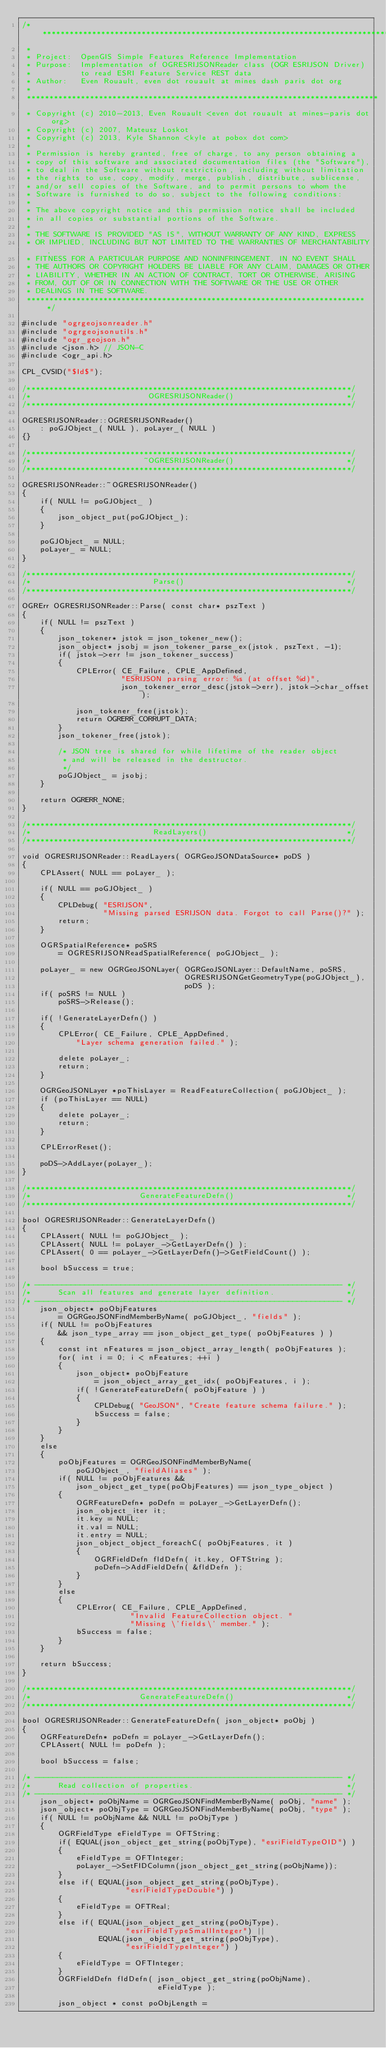<code> <loc_0><loc_0><loc_500><loc_500><_C++_>/******************************************************************************
 *
 * Project:  OpenGIS Simple Features Reference Implementation
 * Purpose:  Implementation of OGRESRIJSONReader class (OGR ESRIJSON Driver)
 *           to read ESRI Feature Service REST data
 * Author:   Even Rouault, even dot rouault at mines dash paris dot org
 *
 ******************************************************************************
 * Copyright (c) 2010-2013, Even Rouault <even dot rouault at mines-paris dot org>
 * Copyright (c) 2007, Mateusz Loskot
 * Copyright (c) 2013, Kyle Shannon <kyle at pobox dot com>
 *
 * Permission is hereby granted, free of charge, to any person obtaining a
 * copy of this software and associated documentation files (the "Software"),
 * to deal in the Software without restriction, including without limitation
 * the rights to use, copy, modify, merge, publish, distribute, sublicense,
 * and/or sell copies of the Software, and to permit persons to whom the
 * Software is furnished to do so, subject to the following conditions:
 *
 * The above copyright notice and this permission notice shall be included
 * in all copies or substantial portions of the Software.
 *
 * THE SOFTWARE IS PROVIDED "AS IS", WITHOUT WARRANTY OF ANY KIND, EXPRESS
 * OR IMPLIED, INCLUDING BUT NOT LIMITED TO THE WARRANTIES OF MERCHANTABILITY,
 * FITNESS FOR A PARTICULAR PURPOSE AND NONINFRINGEMENT. IN NO EVENT SHALL
 * THE AUTHORS OR COPYRIGHT HOLDERS BE LIABLE FOR ANY CLAIM, DAMAGES OR OTHER
 * LIABILITY, WHETHER IN AN ACTION OF CONTRACT, TORT OR OTHERWISE, ARISING
 * FROM, OUT OF OR IN CONNECTION WITH THE SOFTWARE OR THE USE OR OTHER
 * DEALINGS IN THE SOFTWARE.
 ****************************************************************************/

#include "ogrgeojsonreader.h"
#include "ogrgeojsonutils.h"
#include "ogr_geojson.h"
#include <json.h> // JSON-C
#include <ogr_api.h>

CPL_CVSID("$Id$");

/************************************************************************/
/*                          OGRESRIJSONReader()                         */
/************************************************************************/

OGRESRIJSONReader::OGRESRIJSONReader()
    : poGJObject_( NULL ), poLayer_( NULL )
{}

/************************************************************************/
/*                         ~OGRESRIJSONReader()                         */
/************************************************************************/

OGRESRIJSONReader::~OGRESRIJSONReader()
{
    if( NULL != poGJObject_ )
    {
        json_object_put(poGJObject_);
    }

    poGJObject_ = NULL;
    poLayer_ = NULL;
}

/************************************************************************/
/*                           Parse()                                    */
/************************************************************************/

OGRErr OGRESRIJSONReader::Parse( const char* pszText )
{
    if( NULL != pszText )
    {
        json_tokener* jstok = json_tokener_new();
        json_object* jsobj = json_tokener_parse_ex(jstok, pszText, -1);
        if( jstok->err != json_tokener_success)
        {
            CPLError( CE_Failure, CPLE_AppDefined,
                      "ESRIJSON parsing error: %s (at offset %d)",
                      json_tokener_error_desc(jstok->err), jstok->char_offset);

            json_tokener_free(jstok);
            return OGRERR_CORRUPT_DATA;
        }
        json_tokener_free(jstok);

        /* JSON tree is shared for while lifetime of the reader object
         * and will be released in the destructor.
         */
        poGJObject_ = jsobj;
    }

    return OGRERR_NONE;
}

/************************************************************************/
/*                           ReadLayers()                               */
/************************************************************************/

void OGRESRIJSONReader::ReadLayers( OGRGeoJSONDataSource* poDS )
{
    CPLAssert( NULL == poLayer_ );

    if( NULL == poGJObject_ )
    {
        CPLDebug( "ESRIJSON",
                  "Missing parsed ESRIJSON data. Forgot to call Parse()?" );
        return;
    }

    OGRSpatialReference* poSRS
        = OGRESRIJSONReadSpatialReference( poGJObject_ );

    poLayer_ = new OGRGeoJSONLayer( OGRGeoJSONLayer::DefaultName, poSRS,
                                    OGRESRIJSONGetGeometryType(poGJObject_),
                                    poDS );
    if( poSRS != NULL )
        poSRS->Release();

    if( !GenerateLayerDefn() )
    {
        CPLError( CE_Failure, CPLE_AppDefined,
            "Layer schema generation failed." );

        delete poLayer_;
        return;
    }

    OGRGeoJSONLayer *poThisLayer = ReadFeatureCollection( poGJObject_ );
    if (poThisLayer == NULL)
    {
        delete poLayer_;
        return;
    }

    CPLErrorReset();

    poDS->AddLayer(poLayer_);
}

/************************************************************************/
/*                        GenerateFeatureDefn()                         */
/************************************************************************/

bool OGRESRIJSONReader::GenerateLayerDefn()
{
    CPLAssert( NULL != poGJObject_ );
    CPLAssert( NULL != poLayer_->GetLayerDefn() );
    CPLAssert( 0 == poLayer_->GetLayerDefn()->GetFieldCount() );

    bool bSuccess = true;

/* -------------------------------------------------------------------- */
/*      Scan all features and generate layer definition.                */
/* -------------------------------------------------------------------- */
    json_object* poObjFeatures
        = OGRGeoJSONFindMemberByName( poGJObject_, "fields" );
    if( NULL != poObjFeatures
        && json_type_array == json_object_get_type( poObjFeatures ) )
    {
        const int nFeatures = json_object_array_length( poObjFeatures );
        for( int i = 0; i < nFeatures; ++i )
        {
            json_object* poObjFeature
                = json_object_array_get_idx( poObjFeatures, i );
            if( !GenerateFeatureDefn( poObjFeature ) )
            {
                CPLDebug( "GeoJSON", "Create feature schema failure." );
                bSuccess = false;
            }
        }
    }
    else
    {
        poObjFeatures = OGRGeoJSONFindMemberByName(
            poGJObject_, "fieldAliases" );
        if( NULL != poObjFeatures &&
            json_object_get_type(poObjFeatures) == json_type_object )
        {
            OGRFeatureDefn* poDefn = poLayer_->GetLayerDefn();
            json_object_iter it;
            it.key = NULL;
            it.val = NULL;
            it.entry = NULL;
            json_object_object_foreachC( poObjFeatures, it )
            {
                OGRFieldDefn fldDefn( it.key, OFTString );
                poDefn->AddFieldDefn( &fldDefn );
            }
        }
        else
        {
            CPLError( CE_Failure, CPLE_AppDefined,
                        "Invalid FeatureCollection object. "
                        "Missing \'fields\' member." );
            bSuccess = false;
        }
    }

    return bSuccess;
}

/************************************************************************/
/*                        GenerateFeatureDefn()                         */
/************************************************************************/

bool OGRESRIJSONReader::GenerateFeatureDefn( json_object* poObj )
{
    OGRFeatureDefn* poDefn = poLayer_->GetLayerDefn();
    CPLAssert( NULL != poDefn );

    bool bSuccess = false;

/* -------------------------------------------------------------------- */
/*      Read collection of properties.                                  */
/* -------------------------------------------------------------------- */
    json_object* poObjName = OGRGeoJSONFindMemberByName( poObj, "name" );
    json_object* poObjType = OGRGeoJSONFindMemberByName( poObj, "type" );
    if( NULL != poObjName && NULL != poObjType )
    {
        OGRFieldType eFieldType = OFTString;
        if( EQUAL(json_object_get_string(poObjType), "esriFieldTypeOID") )
        {
            eFieldType = OFTInteger;
            poLayer_->SetFIDColumn(json_object_get_string(poObjName));
        }
        else if( EQUAL(json_object_get_string(poObjType),
                       "esriFieldTypeDouble") )
        {
            eFieldType = OFTReal;
        }
        else if( EQUAL(json_object_get_string(poObjType),
                       "esriFieldTypeSmallInteger") ||
                 EQUAL(json_object_get_string(poObjType),
                       "esriFieldTypeInteger") )
        {
            eFieldType = OFTInteger;
        }
        OGRFieldDefn fldDefn( json_object_get_string(poObjName),
                              eFieldType );

        json_object * const poObjLength =</code> 